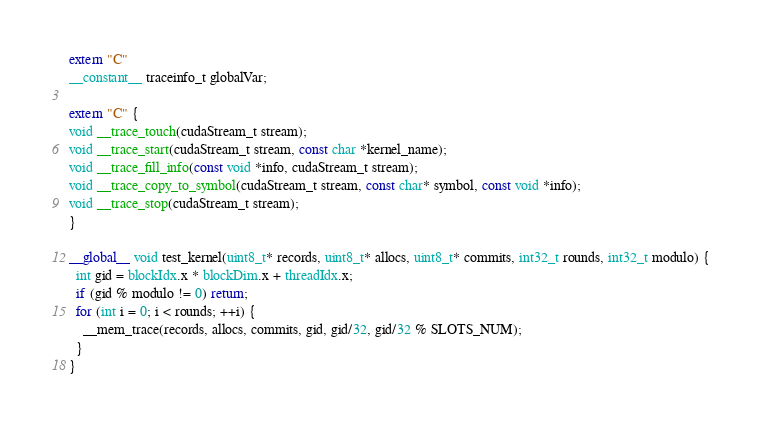<code> <loc_0><loc_0><loc_500><loc_500><_Cuda_>extern "C"
__constant__ traceinfo_t globalVar;

extern "C" {
void __trace_touch(cudaStream_t stream);
void __trace_start(cudaStream_t stream, const char *kernel_name);
void __trace_fill_info(const void *info, cudaStream_t stream);
void __trace_copy_to_symbol(cudaStream_t stream, const char* symbol, const void *info);
void __trace_stop(cudaStream_t stream);
}

__global__ void test_kernel(uint8_t* records, uint8_t* allocs, uint8_t* commits, int32_t rounds, int32_t modulo) {
  int gid = blockIdx.x * blockDim.x + threadIdx.x;
  if (gid % modulo != 0) return;
  for (int i = 0; i < rounds; ++i) {
    __mem_trace(records, allocs, commits, gid, gid/32, gid/32 % SLOTS_NUM);
  }
}
</code> 